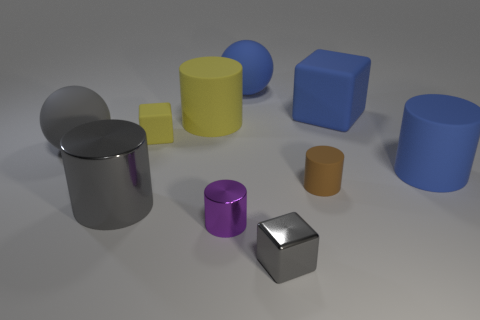Is the shape of the big yellow matte object the same as the small gray metal thing?
Keep it short and to the point. No. Are there an equal number of small purple things on the left side of the large yellow rubber thing and small rubber objects that are behind the brown rubber thing?
Make the answer very short. No. How many other objects are the same material as the small purple object?
Your answer should be very brief. 2. What number of small things are yellow shiny blocks or balls?
Your response must be concise. 0. Are there the same number of small yellow matte blocks that are behind the big rubber cube and big red metal cylinders?
Keep it short and to the point. Yes. Are there any big gray objects in front of the rubber cylinder that is on the right side of the tiny brown cylinder?
Give a very brief answer. Yes. What number of other things are the same color as the large matte cube?
Make the answer very short. 2. What color is the tiny shiny cylinder?
Give a very brief answer. Purple. How big is the cube that is in front of the big yellow rubber thing and behind the tiny purple thing?
Provide a short and direct response. Small. How many things are either gray things that are on the right side of the gray rubber object or tiny gray blocks?
Provide a succinct answer. 2. 